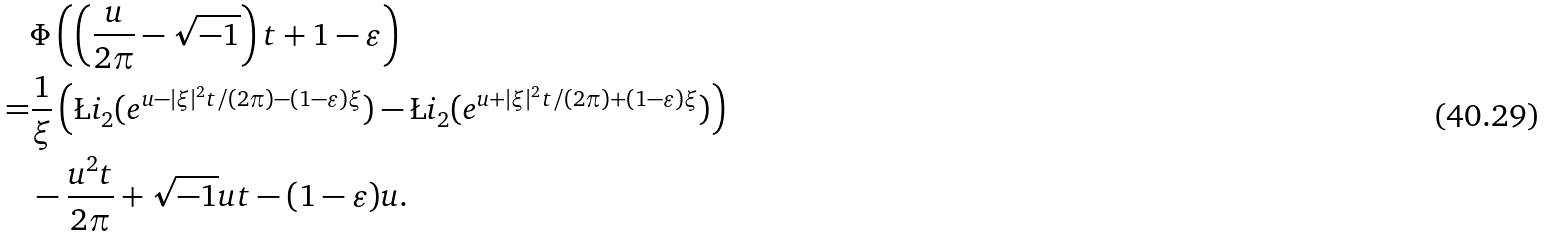Convert formula to latex. <formula><loc_0><loc_0><loc_500><loc_500>& \Phi \left ( \left ( \frac { u } { 2 \pi } - \sqrt { - 1 } \right ) t + 1 - \varepsilon \right ) \\ = & \frac { 1 } { \xi } \left ( \L i _ { 2 } ( e ^ { u - | \xi | ^ { 2 } t / ( 2 \pi ) - ( 1 - \varepsilon ) \xi } ) - \L i _ { 2 } ( e ^ { u + | \xi | ^ { 2 } t / ( 2 \pi ) + ( 1 - \varepsilon ) \xi } ) \right ) \\ & - \frac { u ^ { 2 } t } { 2 \pi } + \sqrt { - 1 } u t - ( 1 - \varepsilon ) u .</formula> 